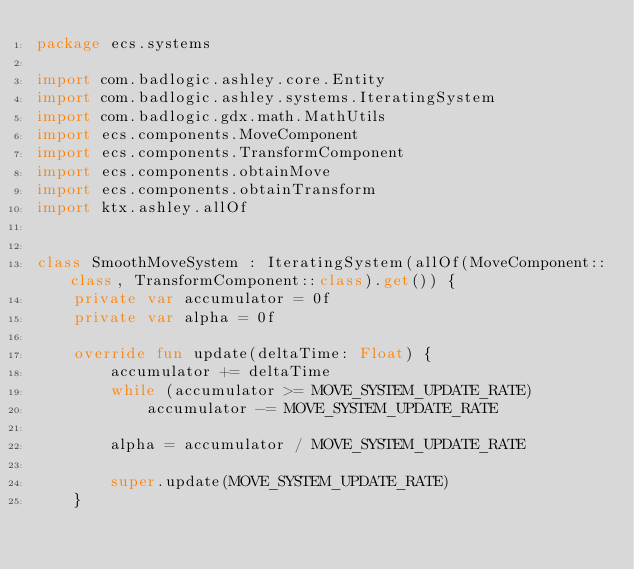Convert code to text. <code><loc_0><loc_0><loc_500><loc_500><_Kotlin_>package ecs.systems

import com.badlogic.ashley.core.Entity
import com.badlogic.ashley.systems.IteratingSystem
import com.badlogic.gdx.math.MathUtils
import ecs.components.MoveComponent
import ecs.components.TransformComponent
import ecs.components.obtainMove
import ecs.components.obtainTransform
import ktx.ashley.allOf


class SmoothMoveSystem : IteratingSystem(allOf(MoveComponent::class, TransformComponent::class).get()) {
    private var accumulator = 0f
    private var alpha = 0f

    override fun update(deltaTime: Float) {
        accumulator += deltaTime
        while (accumulator >= MOVE_SYSTEM_UPDATE_RATE)
            accumulator -= MOVE_SYSTEM_UPDATE_RATE

        alpha = accumulator / MOVE_SYSTEM_UPDATE_RATE

        super.update(MOVE_SYSTEM_UPDATE_RATE)
    }
</code> 